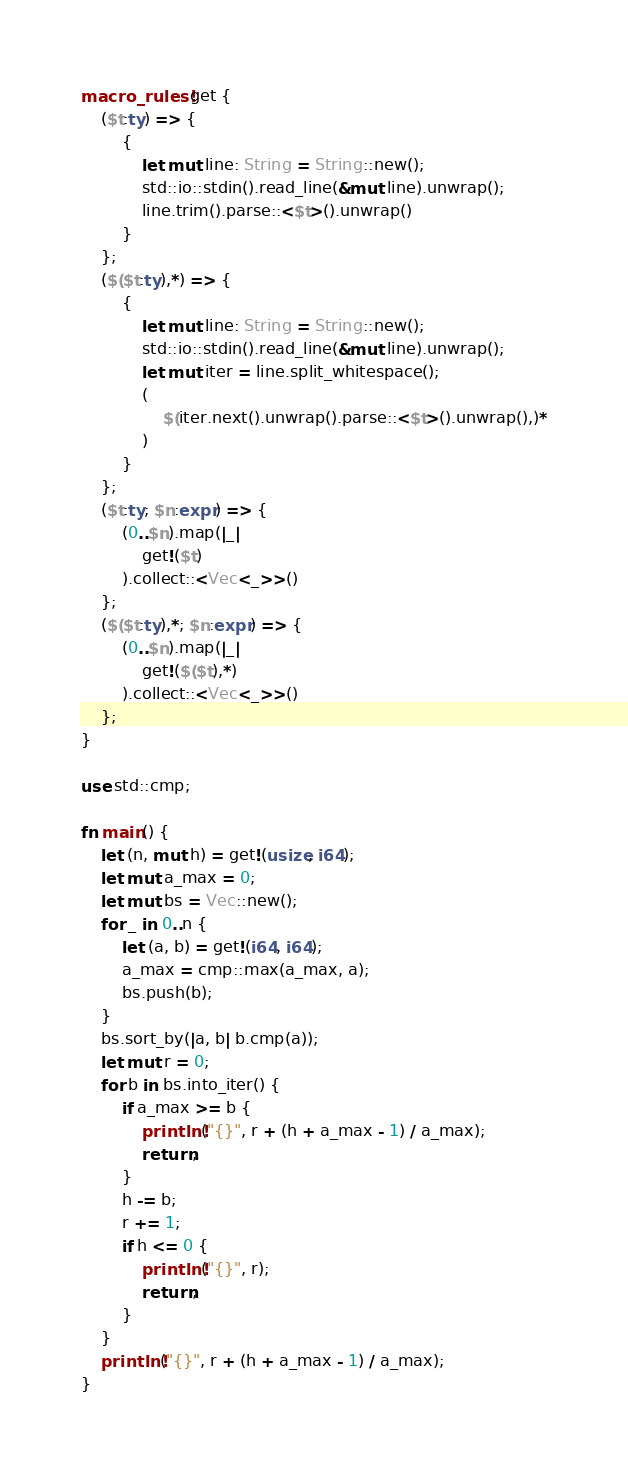<code> <loc_0><loc_0><loc_500><loc_500><_Rust_>macro_rules! get {
    ($t:ty) => {
        {
            let mut line: String = String::new();
            std::io::stdin().read_line(&mut line).unwrap();
            line.trim().parse::<$t>().unwrap()
        }
    };
    ($($t:ty),*) => {
        {
            let mut line: String = String::new();
            std::io::stdin().read_line(&mut line).unwrap();
            let mut iter = line.split_whitespace();
            (
                $(iter.next().unwrap().parse::<$t>().unwrap(),)*
            )
        }
    };
    ($t:ty; $n:expr) => {
        (0..$n).map(|_|
            get!($t)
        ).collect::<Vec<_>>()
    };
    ($($t:ty),*; $n:expr) => {
        (0..$n).map(|_|
            get!($($t),*)
        ).collect::<Vec<_>>()
    };
}

use std::cmp;

fn main() {
    let (n, mut h) = get!(usize, i64);
    let mut a_max = 0;
    let mut bs = Vec::new();
    for _ in 0..n {
        let (a, b) = get!(i64, i64);
        a_max = cmp::max(a_max, a);
        bs.push(b);
    }
    bs.sort_by(|a, b| b.cmp(a));
    let mut r = 0;
    for b in bs.into_iter() {
        if a_max >= b {
            println!("{}", r + (h + a_max - 1) / a_max);
            return;
        }
        h -= b;
        r += 1;
        if h <= 0 {
            println!("{}", r);
            return;
        }
    }
    println!("{}", r + (h + a_max - 1) / a_max);
}</code> 